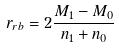Convert formula to latex. <formula><loc_0><loc_0><loc_500><loc_500>r _ { r b } = 2 \frac { M _ { 1 } - M _ { 0 } } { n _ { 1 } + n _ { 0 } }</formula> 